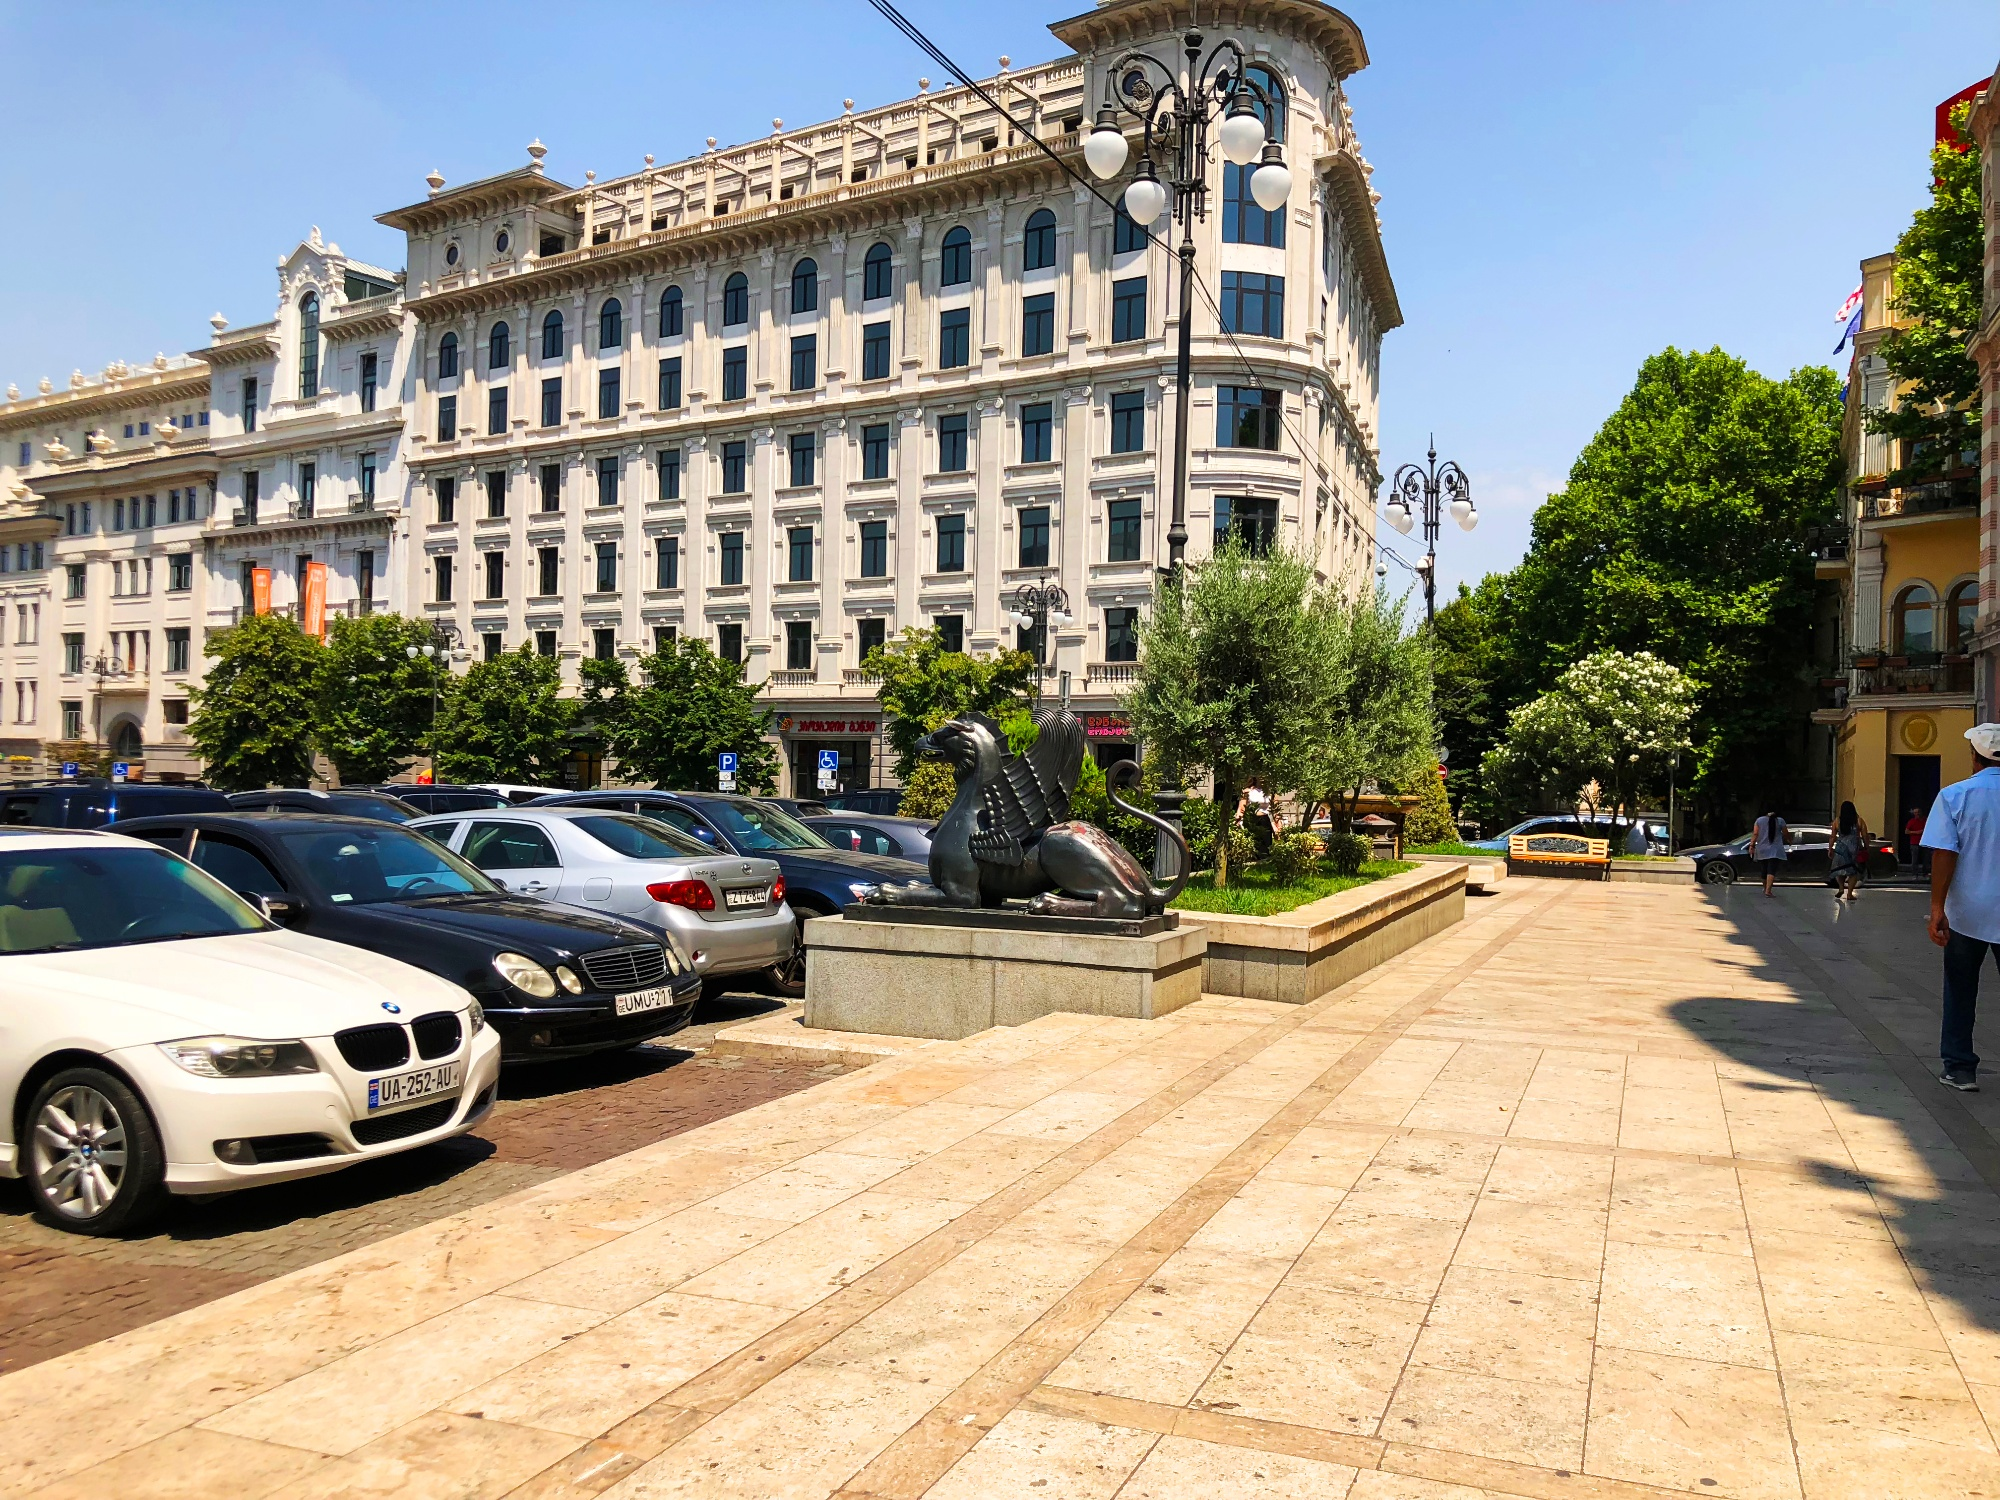Write a detailed description of the given image.
 The image captures a vibrant street scene in a European city. The focal point is a large, white building with intricate architectural details, situated across the street. The building's grandeur is accentuated by the clear blue sky that serves as its backdrop.

In the foreground, the street is lined with several cars, their metallic hues reflecting the sunlight. Notably, a white BMW and a black Mercedes are parked, adding a touch of luxury to the scene.

To the right, a statue of a lion majestically perched on a pedestal catches the eye. A man is seen walking past it, perhaps a local or a tourist, adding a dynamic element to the otherwise static scene.

The lush green trees interspersed throughout the scene suggest it's a sunny day, and the city is teeming with life and activity. The image is a snapshot of urban life, where history and modernity coexist. 